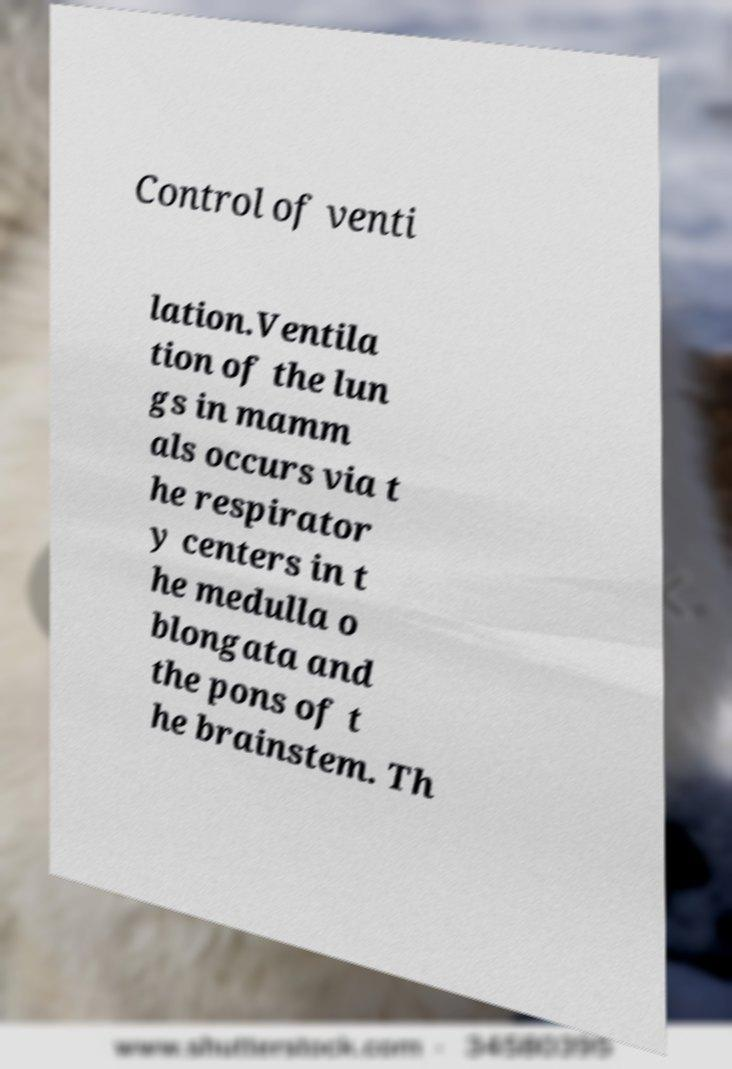Can you accurately transcribe the text from the provided image for me? Control of venti lation.Ventila tion of the lun gs in mamm als occurs via t he respirator y centers in t he medulla o blongata and the pons of t he brainstem. Th 